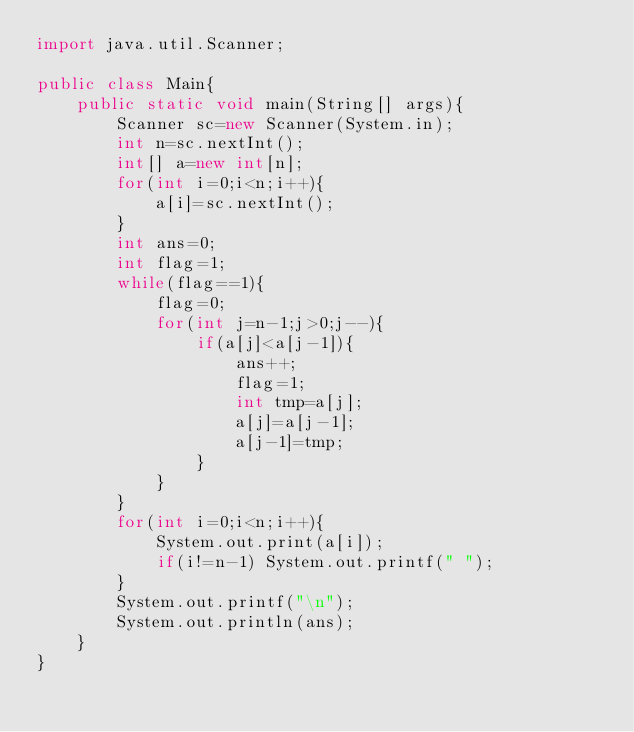Convert code to text. <code><loc_0><loc_0><loc_500><loc_500><_Java_>import java.util.Scanner;

public class Main{
    public static void main(String[] args){
        Scanner sc=new Scanner(System.in);
        int n=sc.nextInt();
        int[] a=new int[n];
        for(int i=0;i<n;i++){
            a[i]=sc.nextInt();
        }
        int ans=0;
        int flag=1;
        while(flag==1){
            flag=0;
            for(int j=n-1;j>0;j--){
                if(a[j]<a[j-1]){
                    ans++;
                    flag=1;
                    int tmp=a[j];
                    a[j]=a[j-1];
                    a[j-1]=tmp;
                }
            }
        }
        for(int i=0;i<n;i++){
            System.out.print(a[i]);
            if(i!=n-1) System.out.printf(" ");
        }
        System.out.printf("\n");
        System.out.println(ans);
    }
}
</code> 